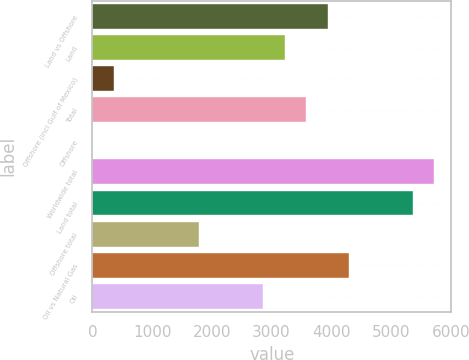Convert chart. <chart><loc_0><loc_0><loc_500><loc_500><bar_chart><fcel>Land vs Offshore<fcel>Land<fcel>Offshore (incl Gulf of Mexico)<fcel>Total<fcel>Offshore<fcel>Worldwide total<fcel>Land total<fcel>Offshore total<fcel>Oil vs Natural Gas<fcel>Oil<nl><fcel>3935.6<fcel>3220.4<fcel>359.6<fcel>3578<fcel>2<fcel>5723.6<fcel>5366<fcel>1790<fcel>4293.2<fcel>2862.8<nl></chart> 